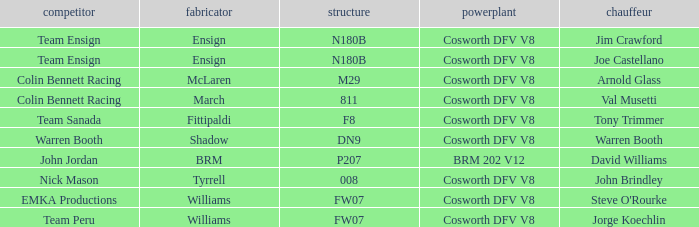Who built the Jim Crawford car? Ensign. 